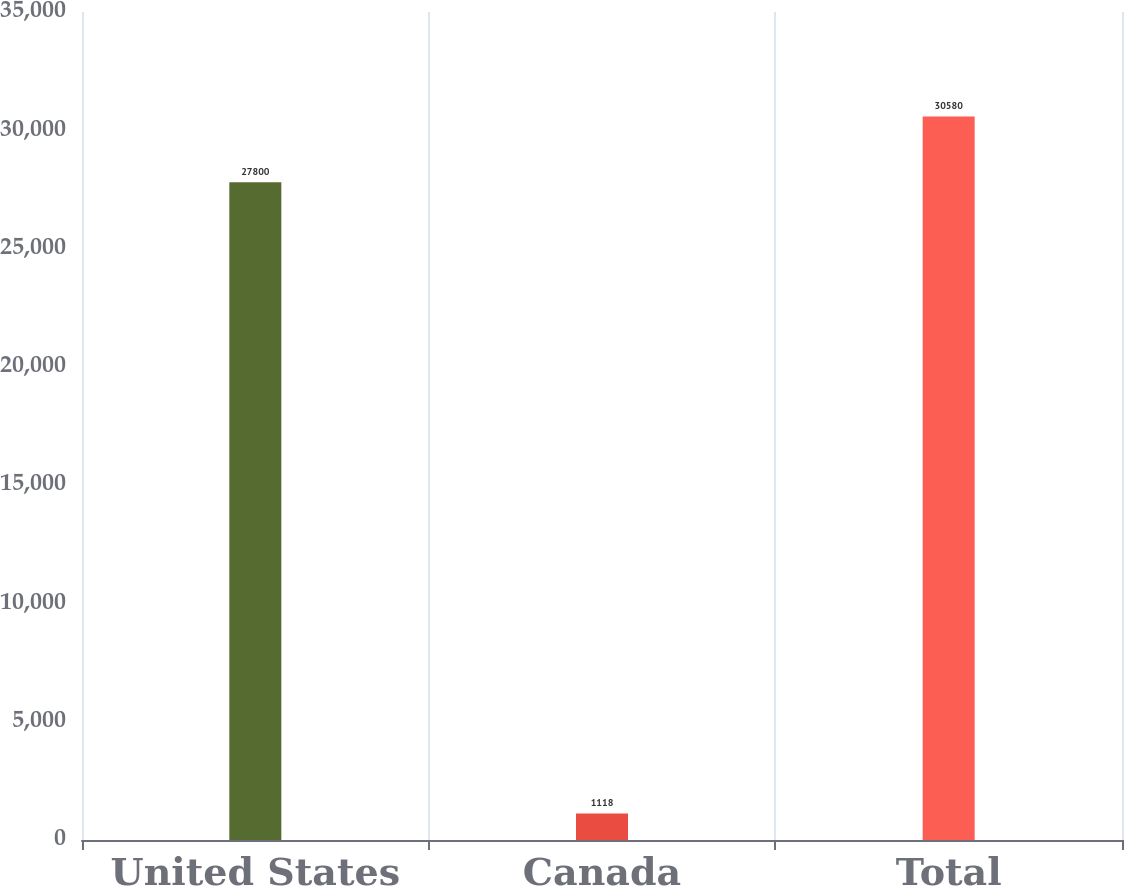Convert chart. <chart><loc_0><loc_0><loc_500><loc_500><bar_chart><fcel>United States<fcel>Canada<fcel>Total<nl><fcel>27800<fcel>1118<fcel>30580<nl></chart> 